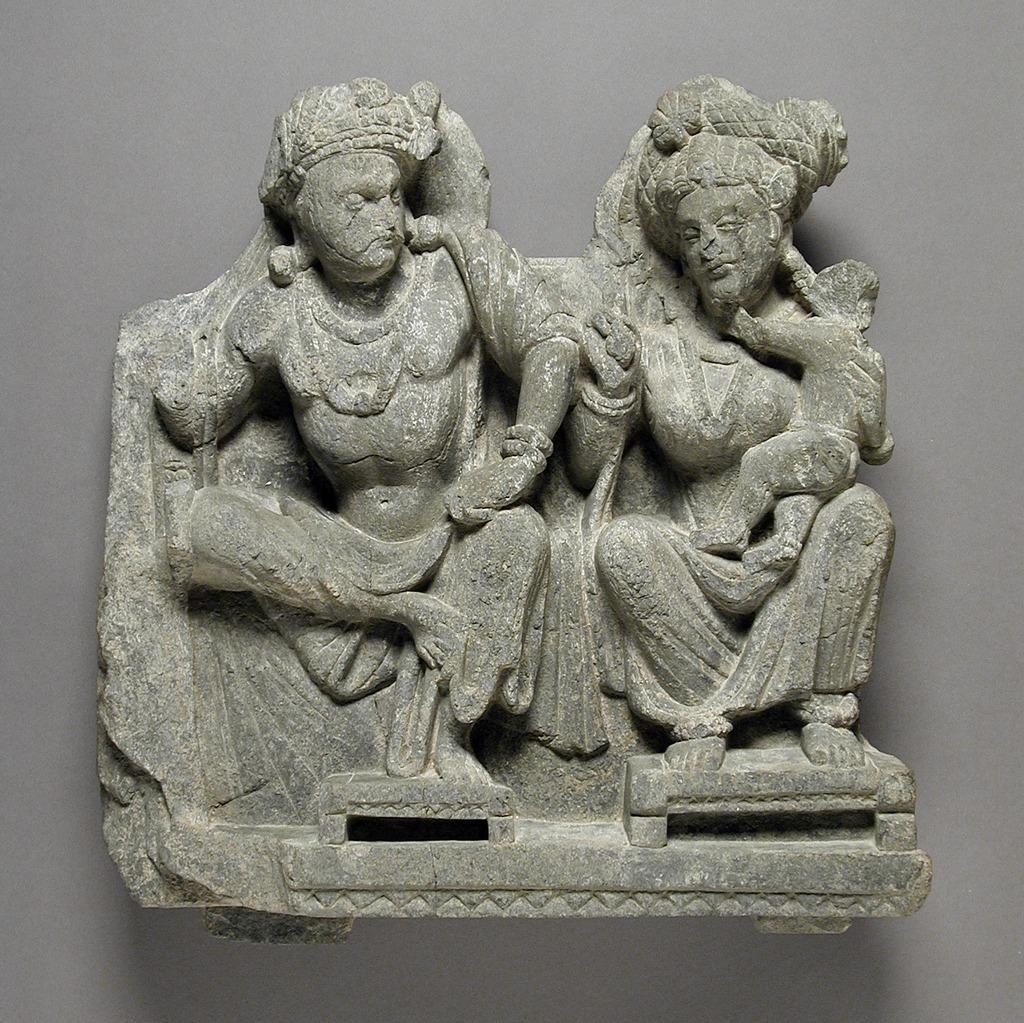Please provide a concise description of this image. There is a statue attached to a wall as we can see in the middle of this image. 